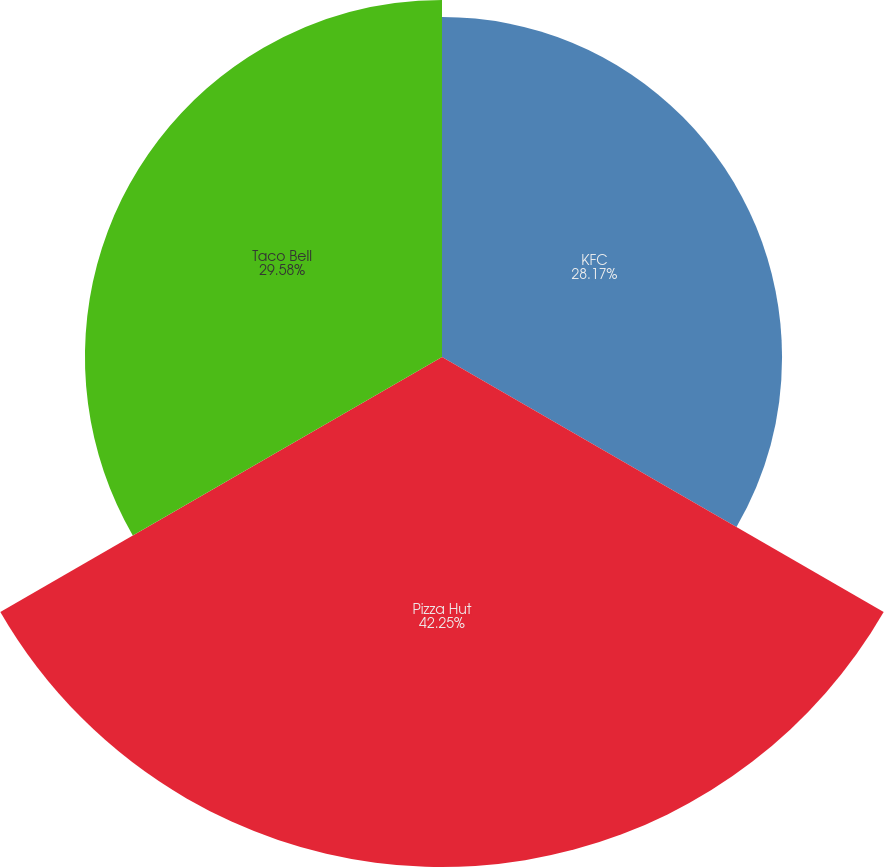Convert chart to OTSL. <chart><loc_0><loc_0><loc_500><loc_500><pie_chart><fcel>KFC<fcel>Pizza Hut<fcel>Taco Bell<nl><fcel>28.17%<fcel>42.25%<fcel>29.58%<nl></chart> 